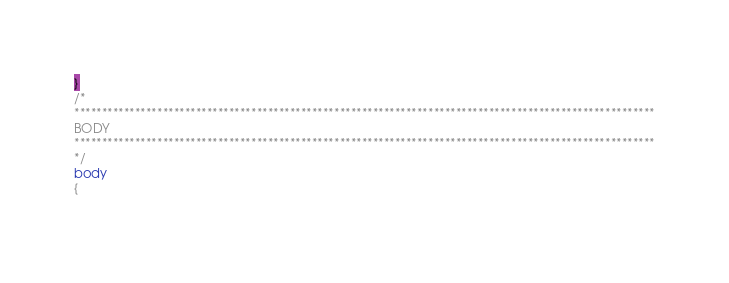Convert code to text. <code><loc_0><loc_0><loc_500><loc_500><_CSS_>}
/*
*********************************************************************************************************
BODY
*********************************************************************************************************
*/
body
{
    </code> 